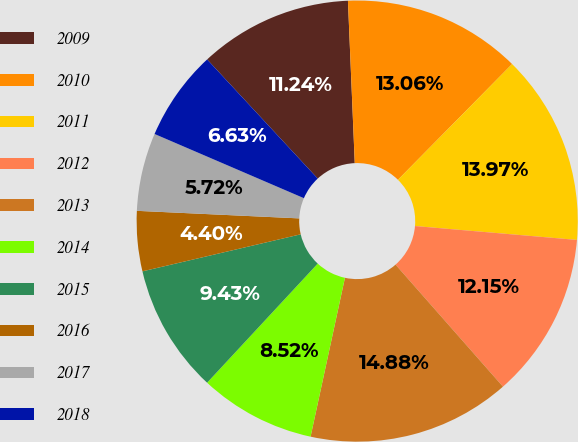Convert chart. <chart><loc_0><loc_0><loc_500><loc_500><pie_chart><fcel>2009<fcel>2010<fcel>2011<fcel>2012<fcel>2013<fcel>2014<fcel>2015<fcel>2016<fcel>2017<fcel>2018<nl><fcel>11.24%<fcel>13.06%<fcel>13.97%<fcel>12.15%<fcel>14.88%<fcel>8.52%<fcel>9.43%<fcel>4.4%<fcel>5.72%<fcel>6.63%<nl></chart> 